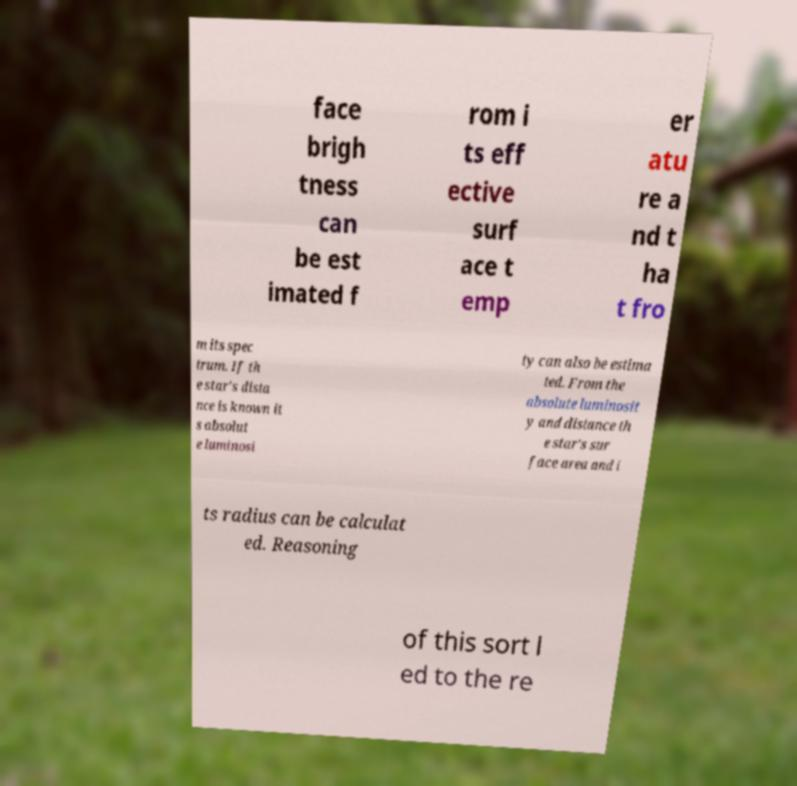For documentation purposes, I need the text within this image transcribed. Could you provide that? face brigh tness can be est imated f rom i ts eff ective surf ace t emp er atu re a nd t ha t fro m its spec trum. If th e star's dista nce is known it s absolut e luminosi ty can also be estima ted. From the absolute luminosit y and distance th e star's sur face area and i ts radius can be calculat ed. Reasoning of this sort l ed to the re 